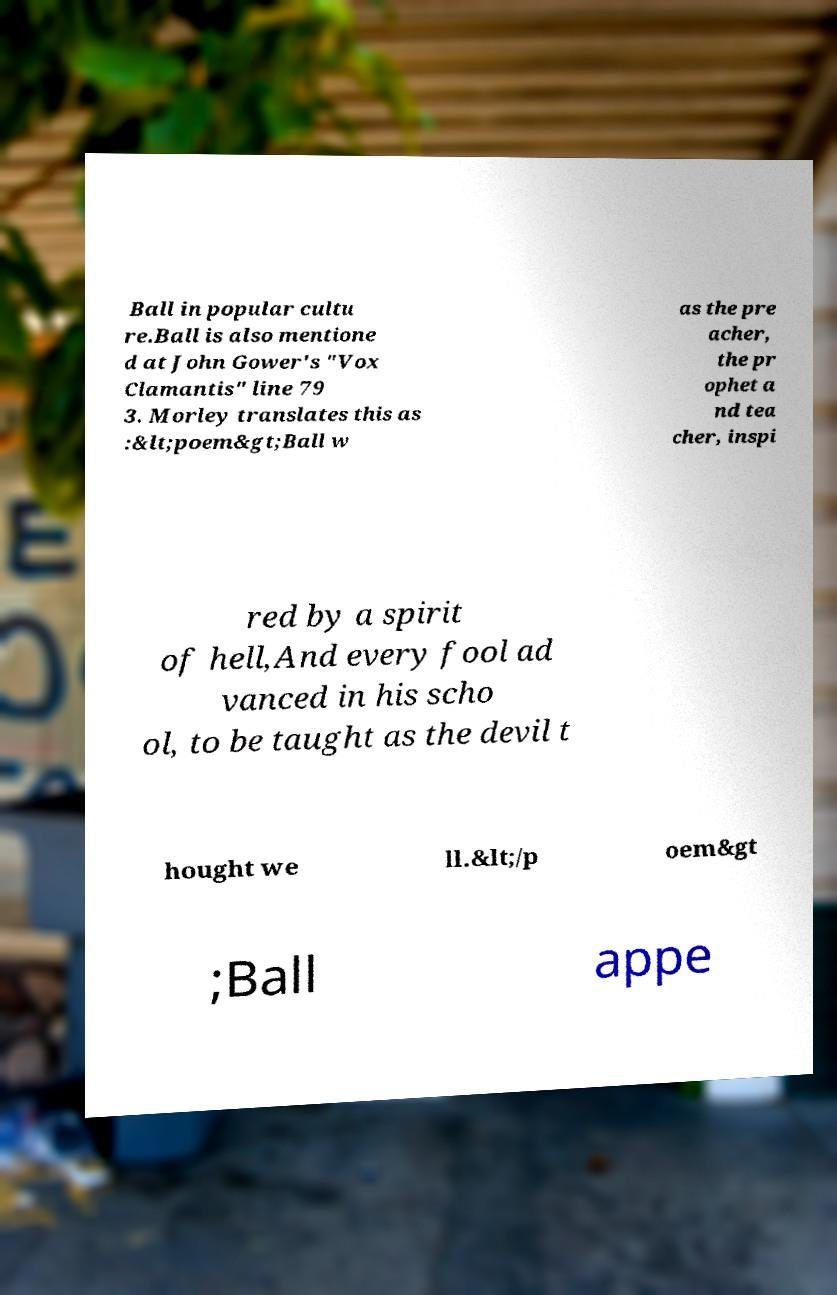Please identify and transcribe the text found in this image. Ball in popular cultu re.Ball is also mentione d at John Gower's "Vox Clamantis" line 79 3. Morley translates this as :&lt;poem&gt;Ball w as the pre acher, the pr ophet a nd tea cher, inspi red by a spirit of hell,And every fool ad vanced in his scho ol, to be taught as the devil t hought we ll.&lt;/p oem&gt ;Ball appe 